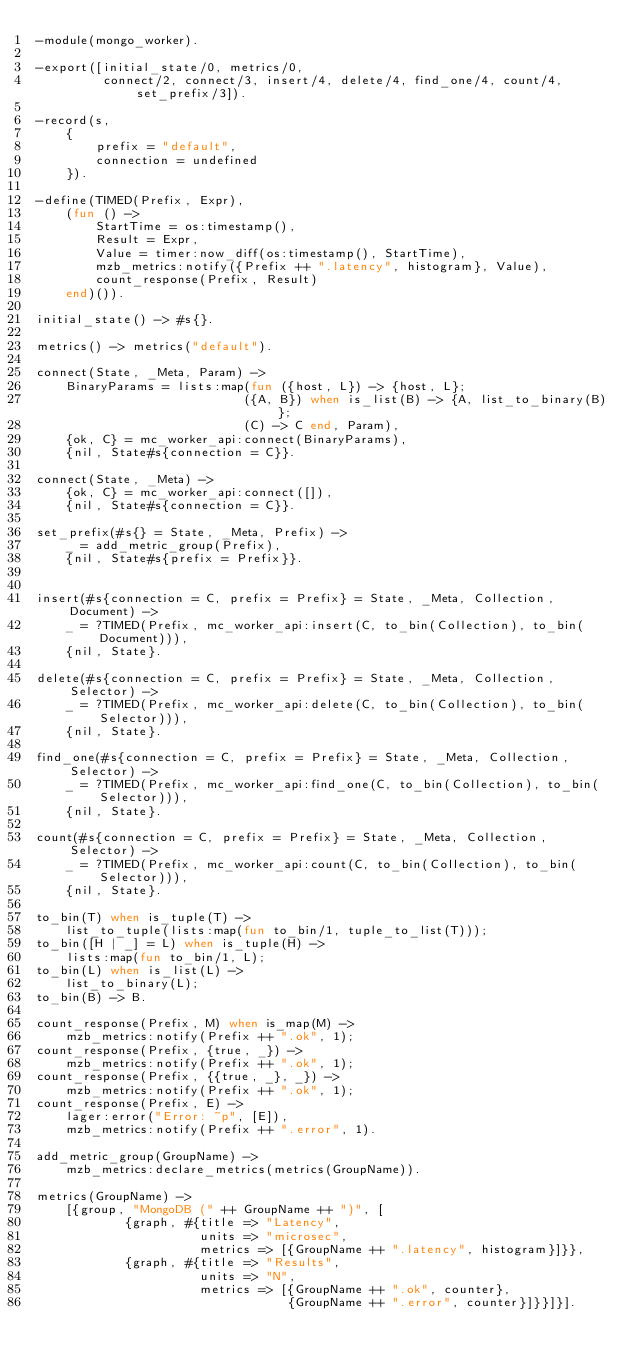<code> <loc_0><loc_0><loc_500><loc_500><_Erlang_>-module(mongo_worker).

-export([initial_state/0, metrics/0,
         connect/2, connect/3, insert/4, delete/4, find_one/4, count/4, set_prefix/3]).

-record(s,
    { 
        prefix = "default",
        connection = undefined
    }).

-define(TIMED(Prefix, Expr),
    (fun () ->
        StartTime = os:timestamp(),
        Result = Expr,
        Value = timer:now_diff(os:timestamp(), StartTime),
        mzb_metrics:notify({Prefix ++ ".latency", histogram}, Value),
        count_response(Prefix, Result)
    end)()).

initial_state() -> #s{}.

metrics() -> metrics("default").

connect(State, _Meta, Param) ->
    BinaryParams = lists:map(fun ({host, L}) -> {host, L};
                            ({A, B}) when is_list(B) -> {A, list_to_binary(B)};
                            (C) -> C end, Param),
    {ok, C} = mc_worker_api:connect(BinaryParams),
    {nil, State#s{connection = C}}.

connect(State, _Meta) ->
    {ok, C} = mc_worker_api:connect([]),
    {nil, State#s{connection = C}}.

set_prefix(#s{} = State, _Meta, Prefix) ->
    _ = add_metric_group(Prefix),
    {nil, State#s{prefix = Prefix}}.


insert(#s{connection = C, prefix = Prefix} = State, _Meta, Collection, Document) ->
    _ = ?TIMED(Prefix, mc_worker_api:insert(C, to_bin(Collection), to_bin(Document))),
    {nil, State}.

delete(#s{connection = C, prefix = Prefix} = State, _Meta, Collection, Selector) ->
    _ = ?TIMED(Prefix, mc_worker_api:delete(C, to_bin(Collection), to_bin(Selector))),
    {nil, State}.

find_one(#s{connection = C, prefix = Prefix} = State, _Meta, Collection, Selector) ->
    _ = ?TIMED(Prefix, mc_worker_api:find_one(C, to_bin(Collection), to_bin(Selector))),
    {nil, State}.

count(#s{connection = C, prefix = Prefix} = State, _Meta, Collection, Selector) ->
    _ = ?TIMED(Prefix, mc_worker_api:count(C, to_bin(Collection), to_bin(Selector))),
    {nil, State}.

to_bin(T) when is_tuple(T) ->
    list_to_tuple(lists:map(fun to_bin/1, tuple_to_list(T)));
to_bin([H | _] = L) when is_tuple(H) ->
    lists:map(fun to_bin/1, L);
to_bin(L) when is_list(L) ->
    list_to_binary(L);
to_bin(B) -> B.

count_response(Prefix, M) when is_map(M) ->
    mzb_metrics:notify(Prefix ++ ".ok", 1);
count_response(Prefix, {true, _}) ->
    mzb_metrics:notify(Prefix ++ ".ok", 1);
count_response(Prefix, {{true, _}, _}) ->
    mzb_metrics:notify(Prefix ++ ".ok", 1);
count_response(Prefix, E) ->
    lager:error("Error: ~p", [E]),
    mzb_metrics:notify(Prefix ++ ".error", 1).

add_metric_group(GroupName) ->
    mzb_metrics:declare_metrics(metrics(GroupName)).

metrics(GroupName) ->
    [{group, "MongoDB (" ++ GroupName ++ ")", [
            {graph, #{title => "Latency",
                      units => "microsec",
                      metrics => [{GroupName ++ ".latency", histogram}]}},
            {graph, #{title => "Results",
                      units => "N",
                      metrics => [{GroupName ++ ".ok", counter},
                                  {GroupName ++ ".error", counter}]}}]}].</code> 